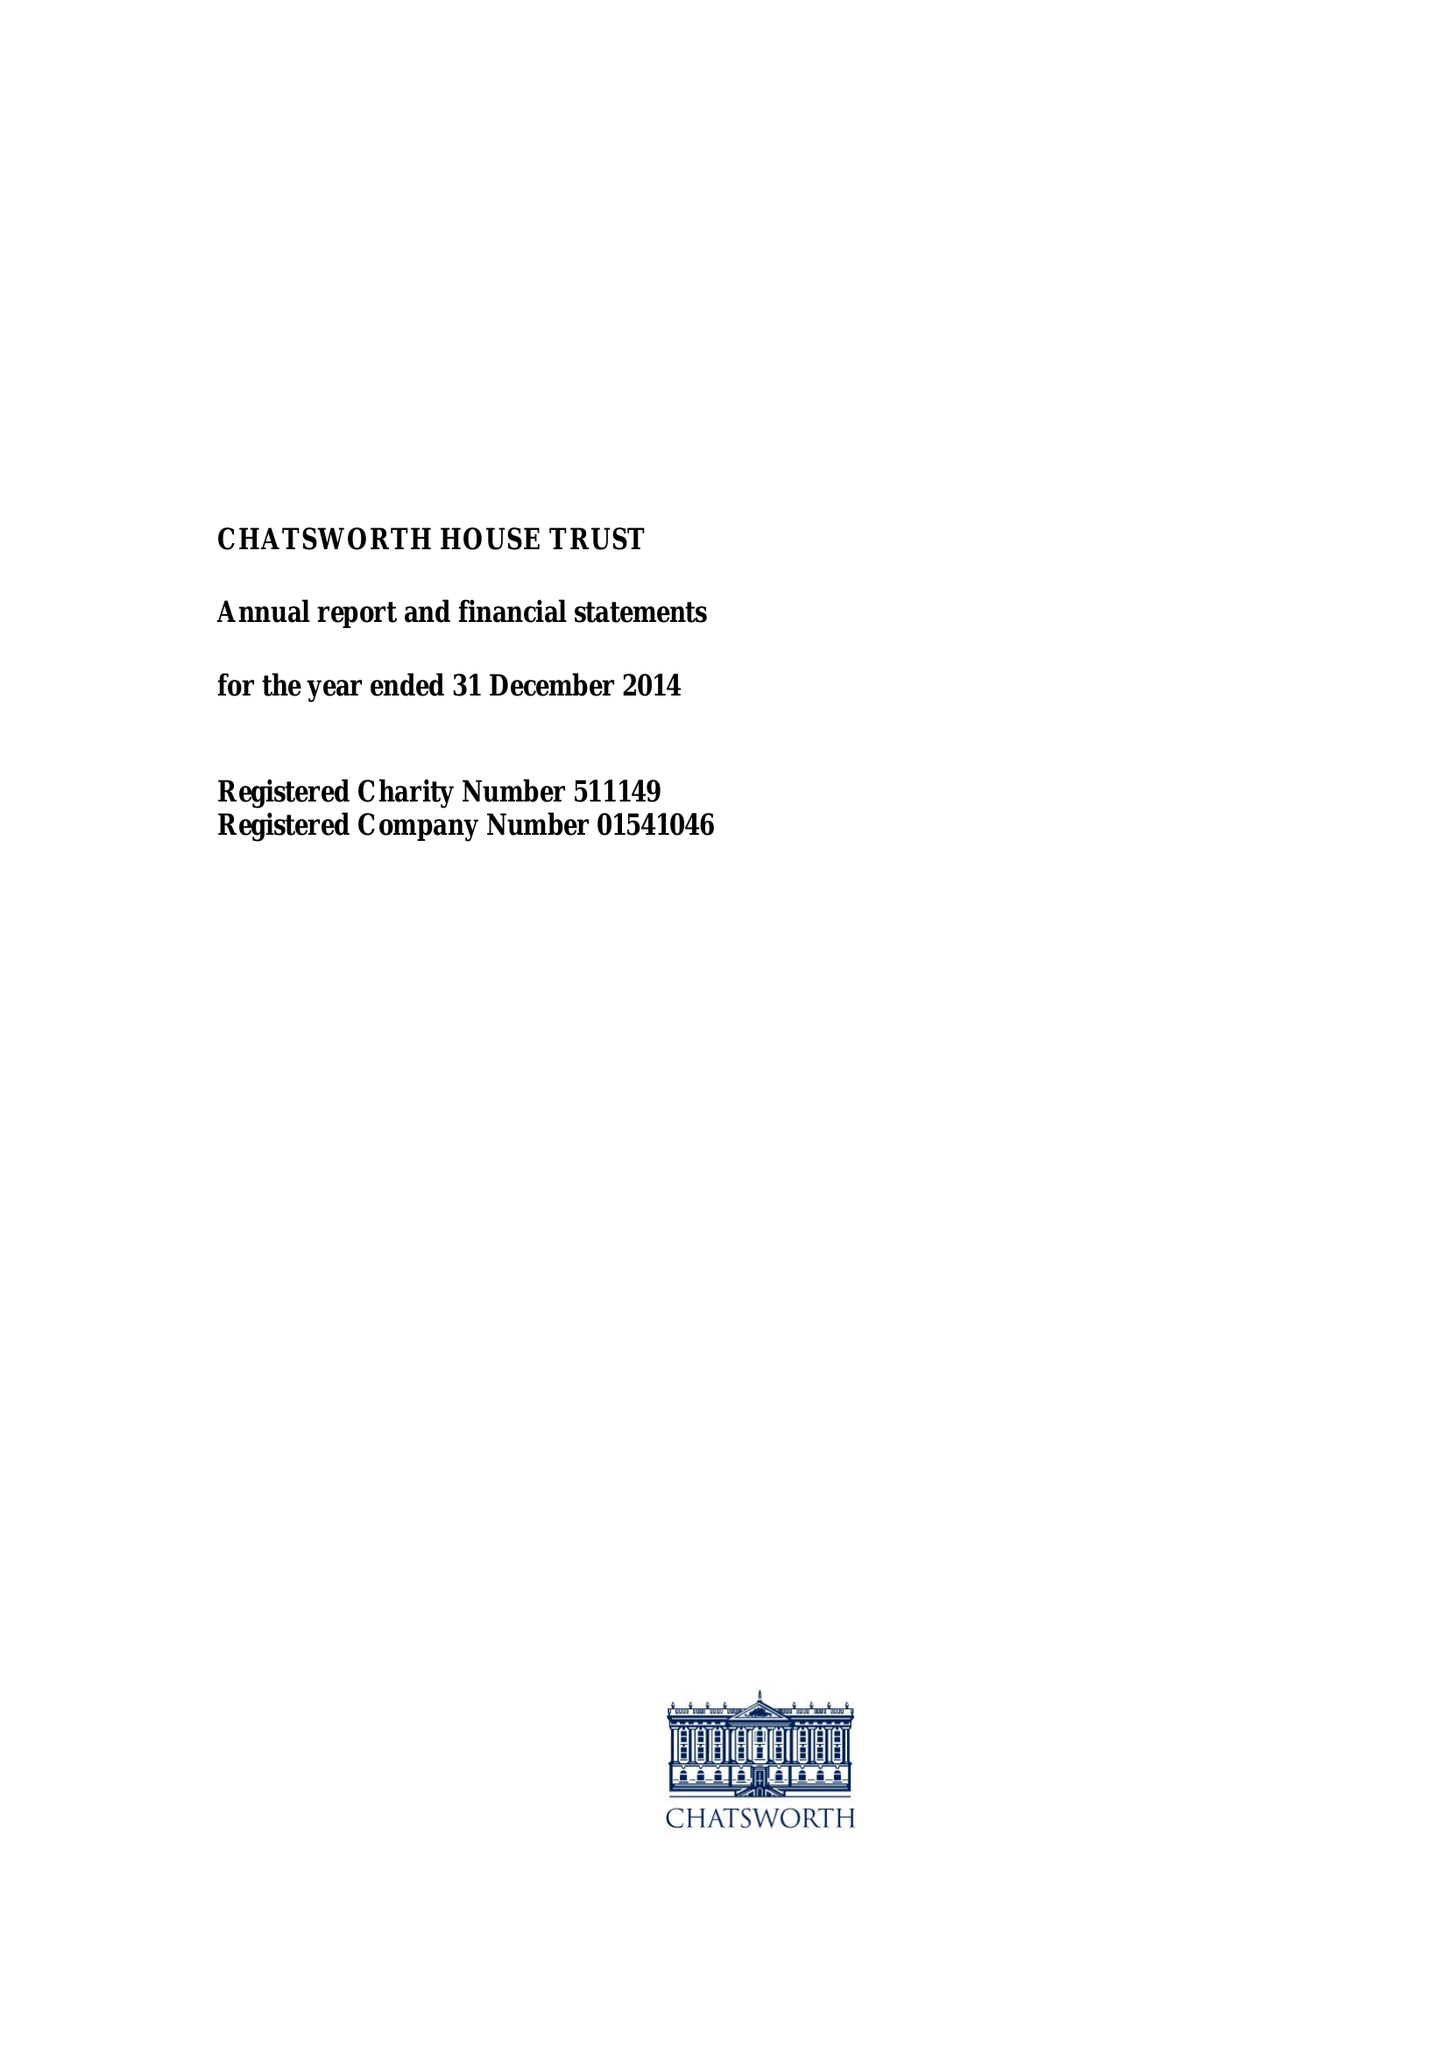What is the value for the address__post_town?
Answer the question using a single word or phrase. BAKEWELL 